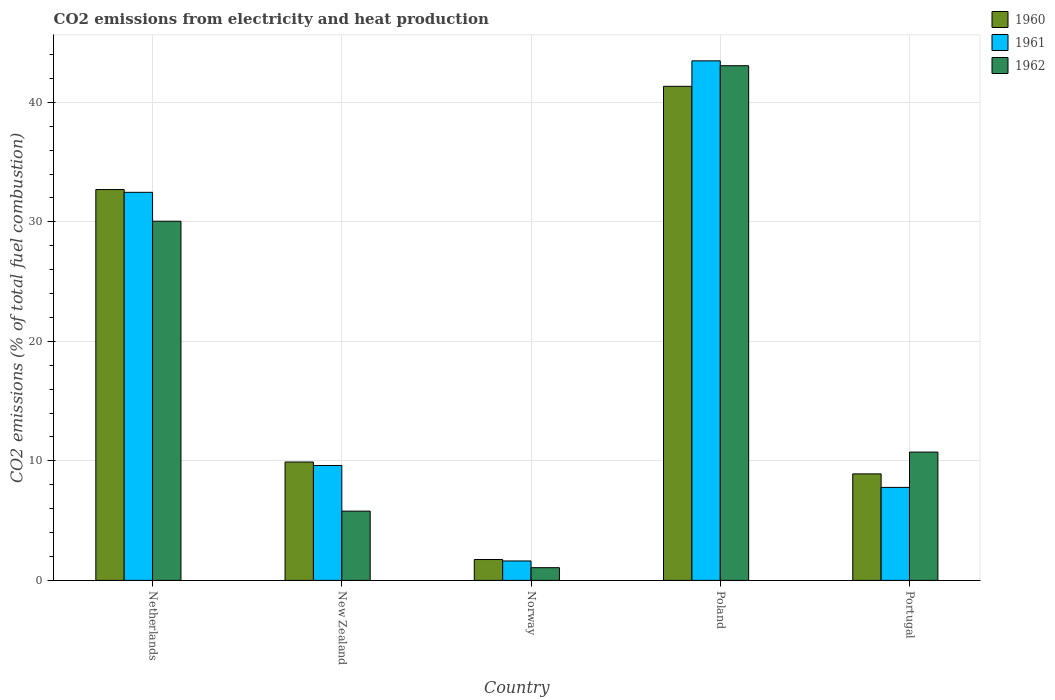How many bars are there on the 3rd tick from the right?
Ensure brevity in your answer.  3. What is the amount of CO2 emitted in 1960 in Netherlands?
Your response must be concise. 32.7. Across all countries, what is the maximum amount of CO2 emitted in 1961?
Offer a terse response. 43.47. Across all countries, what is the minimum amount of CO2 emitted in 1960?
Ensure brevity in your answer.  1.75. In which country was the amount of CO2 emitted in 1962 minimum?
Offer a very short reply. Norway. What is the total amount of CO2 emitted in 1961 in the graph?
Offer a very short reply. 94.96. What is the difference between the amount of CO2 emitted in 1961 in Netherlands and that in Portugal?
Your answer should be very brief. 24.69. What is the difference between the amount of CO2 emitted in 1961 in New Zealand and the amount of CO2 emitted in 1962 in Norway?
Your response must be concise. 8.55. What is the average amount of CO2 emitted in 1961 per country?
Offer a terse response. 18.99. What is the difference between the amount of CO2 emitted of/in 1961 and amount of CO2 emitted of/in 1962 in Netherlands?
Make the answer very short. 2.42. In how many countries, is the amount of CO2 emitted in 1961 greater than 42 %?
Make the answer very short. 1. What is the ratio of the amount of CO2 emitted in 1962 in Netherlands to that in Poland?
Offer a terse response. 0.7. Is the difference between the amount of CO2 emitted in 1961 in Netherlands and New Zealand greater than the difference between the amount of CO2 emitted in 1962 in Netherlands and New Zealand?
Your response must be concise. No. What is the difference between the highest and the second highest amount of CO2 emitted in 1960?
Keep it short and to the point. -8.64. What is the difference between the highest and the lowest amount of CO2 emitted in 1960?
Your answer should be very brief. 39.59. In how many countries, is the amount of CO2 emitted in 1961 greater than the average amount of CO2 emitted in 1961 taken over all countries?
Your answer should be compact. 2. Is the sum of the amount of CO2 emitted in 1961 in New Zealand and Portugal greater than the maximum amount of CO2 emitted in 1962 across all countries?
Offer a very short reply. No. What does the 3rd bar from the left in Poland represents?
Offer a very short reply. 1962. What does the 3rd bar from the right in New Zealand represents?
Your answer should be very brief. 1960. How many bars are there?
Offer a terse response. 15. How many countries are there in the graph?
Your answer should be compact. 5. What is the difference between two consecutive major ticks on the Y-axis?
Offer a very short reply. 10. Are the values on the major ticks of Y-axis written in scientific E-notation?
Make the answer very short. No. Does the graph contain grids?
Offer a terse response. Yes. How are the legend labels stacked?
Provide a succinct answer. Vertical. What is the title of the graph?
Offer a terse response. CO2 emissions from electricity and heat production. What is the label or title of the Y-axis?
Your answer should be very brief. CO2 emissions (% of total fuel combustion). What is the CO2 emissions (% of total fuel combustion) in 1960 in Netherlands?
Offer a very short reply. 32.7. What is the CO2 emissions (% of total fuel combustion) in 1961 in Netherlands?
Your answer should be compact. 32.47. What is the CO2 emissions (% of total fuel combustion) in 1962 in Netherlands?
Provide a succinct answer. 30.05. What is the CO2 emissions (% of total fuel combustion) of 1960 in New Zealand?
Keep it short and to the point. 9.9. What is the CO2 emissions (% of total fuel combustion) in 1961 in New Zealand?
Your answer should be very brief. 9.61. What is the CO2 emissions (% of total fuel combustion) of 1962 in New Zealand?
Your answer should be very brief. 5.79. What is the CO2 emissions (% of total fuel combustion) in 1960 in Norway?
Offer a terse response. 1.75. What is the CO2 emissions (% of total fuel combustion) in 1961 in Norway?
Offer a very short reply. 1.63. What is the CO2 emissions (% of total fuel combustion) in 1962 in Norway?
Give a very brief answer. 1.06. What is the CO2 emissions (% of total fuel combustion) in 1960 in Poland?
Ensure brevity in your answer.  41.34. What is the CO2 emissions (% of total fuel combustion) in 1961 in Poland?
Your answer should be very brief. 43.47. What is the CO2 emissions (% of total fuel combustion) of 1962 in Poland?
Provide a succinct answer. 43.06. What is the CO2 emissions (% of total fuel combustion) of 1960 in Portugal?
Give a very brief answer. 8.91. What is the CO2 emissions (% of total fuel combustion) in 1961 in Portugal?
Your answer should be very brief. 7.78. What is the CO2 emissions (% of total fuel combustion) in 1962 in Portugal?
Keep it short and to the point. 10.73. Across all countries, what is the maximum CO2 emissions (% of total fuel combustion) of 1960?
Give a very brief answer. 41.34. Across all countries, what is the maximum CO2 emissions (% of total fuel combustion) in 1961?
Provide a succinct answer. 43.47. Across all countries, what is the maximum CO2 emissions (% of total fuel combustion) of 1962?
Your response must be concise. 43.06. Across all countries, what is the minimum CO2 emissions (% of total fuel combustion) in 1960?
Provide a short and direct response. 1.75. Across all countries, what is the minimum CO2 emissions (% of total fuel combustion) of 1961?
Offer a terse response. 1.63. Across all countries, what is the minimum CO2 emissions (% of total fuel combustion) in 1962?
Provide a succinct answer. 1.06. What is the total CO2 emissions (% of total fuel combustion) of 1960 in the graph?
Provide a succinct answer. 94.6. What is the total CO2 emissions (% of total fuel combustion) of 1961 in the graph?
Offer a terse response. 94.96. What is the total CO2 emissions (% of total fuel combustion) of 1962 in the graph?
Provide a succinct answer. 90.7. What is the difference between the CO2 emissions (% of total fuel combustion) in 1960 in Netherlands and that in New Zealand?
Provide a succinct answer. 22.8. What is the difference between the CO2 emissions (% of total fuel combustion) of 1961 in Netherlands and that in New Zealand?
Your answer should be compact. 22.86. What is the difference between the CO2 emissions (% of total fuel combustion) of 1962 in Netherlands and that in New Zealand?
Your answer should be very brief. 24.26. What is the difference between the CO2 emissions (% of total fuel combustion) of 1960 in Netherlands and that in Norway?
Offer a very short reply. 30.95. What is the difference between the CO2 emissions (% of total fuel combustion) of 1961 in Netherlands and that in Norway?
Keep it short and to the point. 30.84. What is the difference between the CO2 emissions (% of total fuel combustion) of 1962 in Netherlands and that in Norway?
Keep it short and to the point. 28.99. What is the difference between the CO2 emissions (% of total fuel combustion) of 1960 in Netherlands and that in Poland?
Offer a very short reply. -8.64. What is the difference between the CO2 emissions (% of total fuel combustion) in 1961 in Netherlands and that in Poland?
Keep it short and to the point. -11. What is the difference between the CO2 emissions (% of total fuel combustion) of 1962 in Netherlands and that in Poland?
Offer a very short reply. -13.01. What is the difference between the CO2 emissions (% of total fuel combustion) in 1960 in Netherlands and that in Portugal?
Provide a short and direct response. 23.79. What is the difference between the CO2 emissions (% of total fuel combustion) of 1961 in Netherlands and that in Portugal?
Your answer should be compact. 24.69. What is the difference between the CO2 emissions (% of total fuel combustion) of 1962 in Netherlands and that in Portugal?
Offer a terse response. 19.32. What is the difference between the CO2 emissions (% of total fuel combustion) of 1960 in New Zealand and that in Norway?
Provide a short and direct response. 8.16. What is the difference between the CO2 emissions (% of total fuel combustion) in 1961 in New Zealand and that in Norway?
Provide a short and direct response. 7.99. What is the difference between the CO2 emissions (% of total fuel combustion) of 1962 in New Zealand and that in Norway?
Keep it short and to the point. 4.73. What is the difference between the CO2 emissions (% of total fuel combustion) of 1960 in New Zealand and that in Poland?
Offer a very short reply. -31.43. What is the difference between the CO2 emissions (% of total fuel combustion) in 1961 in New Zealand and that in Poland?
Offer a terse response. -33.86. What is the difference between the CO2 emissions (% of total fuel combustion) in 1962 in New Zealand and that in Poland?
Provide a short and direct response. -37.27. What is the difference between the CO2 emissions (% of total fuel combustion) of 1961 in New Zealand and that in Portugal?
Your response must be concise. 1.83. What is the difference between the CO2 emissions (% of total fuel combustion) in 1962 in New Zealand and that in Portugal?
Offer a very short reply. -4.94. What is the difference between the CO2 emissions (% of total fuel combustion) of 1960 in Norway and that in Poland?
Offer a terse response. -39.59. What is the difference between the CO2 emissions (% of total fuel combustion) in 1961 in Norway and that in Poland?
Offer a very short reply. -41.84. What is the difference between the CO2 emissions (% of total fuel combustion) of 1962 in Norway and that in Poland?
Offer a terse response. -42. What is the difference between the CO2 emissions (% of total fuel combustion) of 1960 in Norway and that in Portugal?
Keep it short and to the point. -7.16. What is the difference between the CO2 emissions (% of total fuel combustion) of 1961 in Norway and that in Portugal?
Offer a terse response. -6.16. What is the difference between the CO2 emissions (% of total fuel combustion) in 1962 in Norway and that in Portugal?
Provide a succinct answer. -9.67. What is the difference between the CO2 emissions (% of total fuel combustion) of 1960 in Poland and that in Portugal?
Make the answer very short. 32.43. What is the difference between the CO2 emissions (% of total fuel combustion) of 1961 in Poland and that in Portugal?
Provide a short and direct response. 35.69. What is the difference between the CO2 emissions (% of total fuel combustion) of 1962 in Poland and that in Portugal?
Ensure brevity in your answer.  32.33. What is the difference between the CO2 emissions (% of total fuel combustion) in 1960 in Netherlands and the CO2 emissions (% of total fuel combustion) in 1961 in New Zealand?
Your answer should be very brief. 23.09. What is the difference between the CO2 emissions (% of total fuel combustion) in 1960 in Netherlands and the CO2 emissions (% of total fuel combustion) in 1962 in New Zealand?
Your answer should be very brief. 26.91. What is the difference between the CO2 emissions (% of total fuel combustion) in 1961 in Netherlands and the CO2 emissions (% of total fuel combustion) in 1962 in New Zealand?
Ensure brevity in your answer.  26.68. What is the difference between the CO2 emissions (% of total fuel combustion) in 1960 in Netherlands and the CO2 emissions (% of total fuel combustion) in 1961 in Norway?
Make the answer very short. 31.07. What is the difference between the CO2 emissions (% of total fuel combustion) in 1960 in Netherlands and the CO2 emissions (% of total fuel combustion) in 1962 in Norway?
Offer a very short reply. 31.64. What is the difference between the CO2 emissions (% of total fuel combustion) in 1961 in Netherlands and the CO2 emissions (% of total fuel combustion) in 1962 in Norway?
Your answer should be compact. 31.41. What is the difference between the CO2 emissions (% of total fuel combustion) of 1960 in Netherlands and the CO2 emissions (% of total fuel combustion) of 1961 in Poland?
Provide a succinct answer. -10.77. What is the difference between the CO2 emissions (% of total fuel combustion) in 1960 in Netherlands and the CO2 emissions (% of total fuel combustion) in 1962 in Poland?
Give a very brief answer. -10.36. What is the difference between the CO2 emissions (% of total fuel combustion) of 1961 in Netherlands and the CO2 emissions (% of total fuel combustion) of 1962 in Poland?
Make the answer very short. -10.59. What is the difference between the CO2 emissions (% of total fuel combustion) of 1960 in Netherlands and the CO2 emissions (% of total fuel combustion) of 1961 in Portugal?
Keep it short and to the point. 24.92. What is the difference between the CO2 emissions (% of total fuel combustion) of 1960 in Netherlands and the CO2 emissions (% of total fuel combustion) of 1962 in Portugal?
Make the answer very short. 21.97. What is the difference between the CO2 emissions (% of total fuel combustion) of 1961 in Netherlands and the CO2 emissions (% of total fuel combustion) of 1962 in Portugal?
Ensure brevity in your answer.  21.73. What is the difference between the CO2 emissions (% of total fuel combustion) in 1960 in New Zealand and the CO2 emissions (% of total fuel combustion) in 1961 in Norway?
Provide a succinct answer. 8.28. What is the difference between the CO2 emissions (% of total fuel combustion) of 1960 in New Zealand and the CO2 emissions (% of total fuel combustion) of 1962 in Norway?
Provide a succinct answer. 8.84. What is the difference between the CO2 emissions (% of total fuel combustion) in 1961 in New Zealand and the CO2 emissions (% of total fuel combustion) in 1962 in Norway?
Your answer should be very brief. 8.55. What is the difference between the CO2 emissions (% of total fuel combustion) of 1960 in New Zealand and the CO2 emissions (% of total fuel combustion) of 1961 in Poland?
Your answer should be compact. -33.57. What is the difference between the CO2 emissions (% of total fuel combustion) of 1960 in New Zealand and the CO2 emissions (% of total fuel combustion) of 1962 in Poland?
Ensure brevity in your answer.  -33.16. What is the difference between the CO2 emissions (% of total fuel combustion) of 1961 in New Zealand and the CO2 emissions (% of total fuel combustion) of 1962 in Poland?
Your answer should be compact. -33.45. What is the difference between the CO2 emissions (% of total fuel combustion) of 1960 in New Zealand and the CO2 emissions (% of total fuel combustion) of 1961 in Portugal?
Your answer should be very brief. 2.12. What is the difference between the CO2 emissions (% of total fuel combustion) of 1960 in New Zealand and the CO2 emissions (% of total fuel combustion) of 1962 in Portugal?
Your answer should be compact. -0.83. What is the difference between the CO2 emissions (% of total fuel combustion) in 1961 in New Zealand and the CO2 emissions (% of total fuel combustion) in 1962 in Portugal?
Your answer should be compact. -1.12. What is the difference between the CO2 emissions (% of total fuel combustion) of 1960 in Norway and the CO2 emissions (% of total fuel combustion) of 1961 in Poland?
Keep it short and to the point. -41.72. What is the difference between the CO2 emissions (% of total fuel combustion) in 1960 in Norway and the CO2 emissions (% of total fuel combustion) in 1962 in Poland?
Offer a terse response. -41.31. What is the difference between the CO2 emissions (% of total fuel combustion) in 1961 in Norway and the CO2 emissions (% of total fuel combustion) in 1962 in Poland?
Ensure brevity in your answer.  -41.44. What is the difference between the CO2 emissions (% of total fuel combustion) in 1960 in Norway and the CO2 emissions (% of total fuel combustion) in 1961 in Portugal?
Provide a short and direct response. -6.03. What is the difference between the CO2 emissions (% of total fuel combustion) of 1960 in Norway and the CO2 emissions (% of total fuel combustion) of 1962 in Portugal?
Your answer should be compact. -8.99. What is the difference between the CO2 emissions (% of total fuel combustion) of 1961 in Norway and the CO2 emissions (% of total fuel combustion) of 1962 in Portugal?
Your answer should be compact. -9.11. What is the difference between the CO2 emissions (% of total fuel combustion) of 1960 in Poland and the CO2 emissions (% of total fuel combustion) of 1961 in Portugal?
Ensure brevity in your answer.  33.56. What is the difference between the CO2 emissions (% of total fuel combustion) of 1960 in Poland and the CO2 emissions (% of total fuel combustion) of 1962 in Portugal?
Make the answer very short. 30.6. What is the difference between the CO2 emissions (% of total fuel combustion) of 1961 in Poland and the CO2 emissions (% of total fuel combustion) of 1962 in Portugal?
Keep it short and to the point. 32.73. What is the average CO2 emissions (% of total fuel combustion) in 1960 per country?
Give a very brief answer. 18.92. What is the average CO2 emissions (% of total fuel combustion) of 1961 per country?
Your response must be concise. 18.99. What is the average CO2 emissions (% of total fuel combustion) of 1962 per country?
Provide a succinct answer. 18.14. What is the difference between the CO2 emissions (% of total fuel combustion) in 1960 and CO2 emissions (% of total fuel combustion) in 1961 in Netherlands?
Offer a terse response. 0.23. What is the difference between the CO2 emissions (% of total fuel combustion) in 1960 and CO2 emissions (% of total fuel combustion) in 1962 in Netherlands?
Provide a succinct answer. 2.65. What is the difference between the CO2 emissions (% of total fuel combustion) of 1961 and CO2 emissions (% of total fuel combustion) of 1962 in Netherlands?
Keep it short and to the point. 2.42. What is the difference between the CO2 emissions (% of total fuel combustion) of 1960 and CO2 emissions (% of total fuel combustion) of 1961 in New Zealand?
Offer a very short reply. 0.29. What is the difference between the CO2 emissions (% of total fuel combustion) of 1960 and CO2 emissions (% of total fuel combustion) of 1962 in New Zealand?
Keep it short and to the point. 4.11. What is the difference between the CO2 emissions (% of total fuel combustion) of 1961 and CO2 emissions (% of total fuel combustion) of 1962 in New Zealand?
Make the answer very short. 3.82. What is the difference between the CO2 emissions (% of total fuel combustion) of 1960 and CO2 emissions (% of total fuel combustion) of 1961 in Norway?
Offer a very short reply. 0.12. What is the difference between the CO2 emissions (% of total fuel combustion) in 1960 and CO2 emissions (% of total fuel combustion) in 1962 in Norway?
Ensure brevity in your answer.  0.68. What is the difference between the CO2 emissions (% of total fuel combustion) in 1961 and CO2 emissions (% of total fuel combustion) in 1962 in Norway?
Your response must be concise. 0.56. What is the difference between the CO2 emissions (% of total fuel combustion) in 1960 and CO2 emissions (% of total fuel combustion) in 1961 in Poland?
Keep it short and to the point. -2.13. What is the difference between the CO2 emissions (% of total fuel combustion) in 1960 and CO2 emissions (% of total fuel combustion) in 1962 in Poland?
Your answer should be very brief. -1.72. What is the difference between the CO2 emissions (% of total fuel combustion) in 1961 and CO2 emissions (% of total fuel combustion) in 1962 in Poland?
Offer a terse response. 0.41. What is the difference between the CO2 emissions (% of total fuel combustion) of 1960 and CO2 emissions (% of total fuel combustion) of 1961 in Portugal?
Offer a very short reply. 1.13. What is the difference between the CO2 emissions (% of total fuel combustion) in 1960 and CO2 emissions (% of total fuel combustion) in 1962 in Portugal?
Ensure brevity in your answer.  -1.82. What is the difference between the CO2 emissions (% of total fuel combustion) of 1961 and CO2 emissions (% of total fuel combustion) of 1962 in Portugal?
Your answer should be compact. -2.95. What is the ratio of the CO2 emissions (% of total fuel combustion) in 1960 in Netherlands to that in New Zealand?
Your answer should be very brief. 3.3. What is the ratio of the CO2 emissions (% of total fuel combustion) of 1961 in Netherlands to that in New Zealand?
Your answer should be very brief. 3.38. What is the ratio of the CO2 emissions (% of total fuel combustion) of 1962 in Netherlands to that in New Zealand?
Your answer should be compact. 5.19. What is the ratio of the CO2 emissions (% of total fuel combustion) in 1960 in Netherlands to that in Norway?
Give a very brief answer. 18.72. What is the ratio of the CO2 emissions (% of total fuel combustion) in 1961 in Netherlands to that in Norway?
Ensure brevity in your answer.  19.98. What is the ratio of the CO2 emissions (% of total fuel combustion) in 1962 in Netherlands to that in Norway?
Your response must be concise. 28.27. What is the ratio of the CO2 emissions (% of total fuel combustion) of 1960 in Netherlands to that in Poland?
Ensure brevity in your answer.  0.79. What is the ratio of the CO2 emissions (% of total fuel combustion) in 1961 in Netherlands to that in Poland?
Offer a terse response. 0.75. What is the ratio of the CO2 emissions (% of total fuel combustion) in 1962 in Netherlands to that in Poland?
Make the answer very short. 0.7. What is the ratio of the CO2 emissions (% of total fuel combustion) in 1960 in Netherlands to that in Portugal?
Provide a succinct answer. 3.67. What is the ratio of the CO2 emissions (% of total fuel combustion) of 1961 in Netherlands to that in Portugal?
Your answer should be compact. 4.17. What is the ratio of the CO2 emissions (% of total fuel combustion) of 1962 in Netherlands to that in Portugal?
Provide a short and direct response. 2.8. What is the ratio of the CO2 emissions (% of total fuel combustion) of 1960 in New Zealand to that in Norway?
Offer a terse response. 5.67. What is the ratio of the CO2 emissions (% of total fuel combustion) of 1961 in New Zealand to that in Norway?
Provide a succinct answer. 5.91. What is the ratio of the CO2 emissions (% of total fuel combustion) of 1962 in New Zealand to that in Norway?
Ensure brevity in your answer.  5.45. What is the ratio of the CO2 emissions (% of total fuel combustion) of 1960 in New Zealand to that in Poland?
Provide a short and direct response. 0.24. What is the ratio of the CO2 emissions (% of total fuel combustion) in 1961 in New Zealand to that in Poland?
Provide a succinct answer. 0.22. What is the ratio of the CO2 emissions (% of total fuel combustion) of 1962 in New Zealand to that in Poland?
Your answer should be very brief. 0.13. What is the ratio of the CO2 emissions (% of total fuel combustion) of 1960 in New Zealand to that in Portugal?
Ensure brevity in your answer.  1.11. What is the ratio of the CO2 emissions (% of total fuel combustion) of 1961 in New Zealand to that in Portugal?
Your answer should be very brief. 1.24. What is the ratio of the CO2 emissions (% of total fuel combustion) of 1962 in New Zealand to that in Portugal?
Your answer should be very brief. 0.54. What is the ratio of the CO2 emissions (% of total fuel combustion) of 1960 in Norway to that in Poland?
Your response must be concise. 0.04. What is the ratio of the CO2 emissions (% of total fuel combustion) in 1961 in Norway to that in Poland?
Offer a terse response. 0.04. What is the ratio of the CO2 emissions (% of total fuel combustion) in 1962 in Norway to that in Poland?
Your response must be concise. 0.02. What is the ratio of the CO2 emissions (% of total fuel combustion) in 1960 in Norway to that in Portugal?
Make the answer very short. 0.2. What is the ratio of the CO2 emissions (% of total fuel combustion) of 1961 in Norway to that in Portugal?
Offer a terse response. 0.21. What is the ratio of the CO2 emissions (% of total fuel combustion) in 1962 in Norway to that in Portugal?
Provide a short and direct response. 0.1. What is the ratio of the CO2 emissions (% of total fuel combustion) of 1960 in Poland to that in Portugal?
Keep it short and to the point. 4.64. What is the ratio of the CO2 emissions (% of total fuel combustion) in 1961 in Poland to that in Portugal?
Offer a very short reply. 5.59. What is the ratio of the CO2 emissions (% of total fuel combustion) of 1962 in Poland to that in Portugal?
Offer a terse response. 4.01. What is the difference between the highest and the second highest CO2 emissions (% of total fuel combustion) of 1960?
Your answer should be compact. 8.64. What is the difference between the highest and the second highest CO2 emissions (% of total fuel combustion) in 1961?
Make the answer very short. 11. What is the difference between the highest and the second highest CO2 emissions (% of total fuel combustion) in 1962?
Give a very brief answer. 13.01. What is the difference between the highest and the lowest CO2 emissions (% of total fuel combustion) in 1960?
Keep it short and to the point. 39.59. What is the difference between the highest and the lowest CO2 emissions (% of total fuel combustion) in 1961?
Provide a succinct answer. 41.84. What is the difference between the highest and the lowest CO2 emissions (% of total fuel combustion) in 1962?
Provide a succinct answer. 42. 